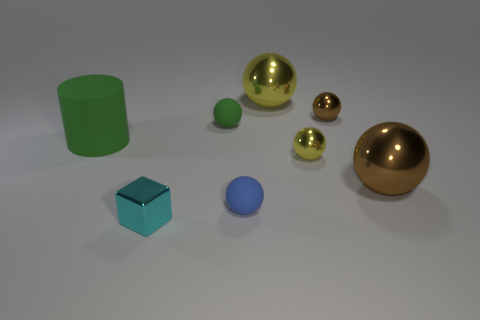Subtract all brown spheres. How many were subtracted if there are1brown spheres left? 1 Subtract all brown metallic balls. How many balls are left? 4 Subtract all blue balls. How many balls are left? 5 Subtract all blue spheres. Subtract all green cylinders. How many spheres are left? 5 Add 1 objects. How many objects exist? 9 Subtract all cubes. How many objects are left? 7 Subtract 1 green cylinders. How many objects are left? 7 Subtract all big green matte cubes. Subtract all tiny balls. How many objects are left? 4 Add 2 spheres. How many spheres are left? 8 Add 6 tiny gray rubber objects. How many tiny gray rubber objects exist? 6 